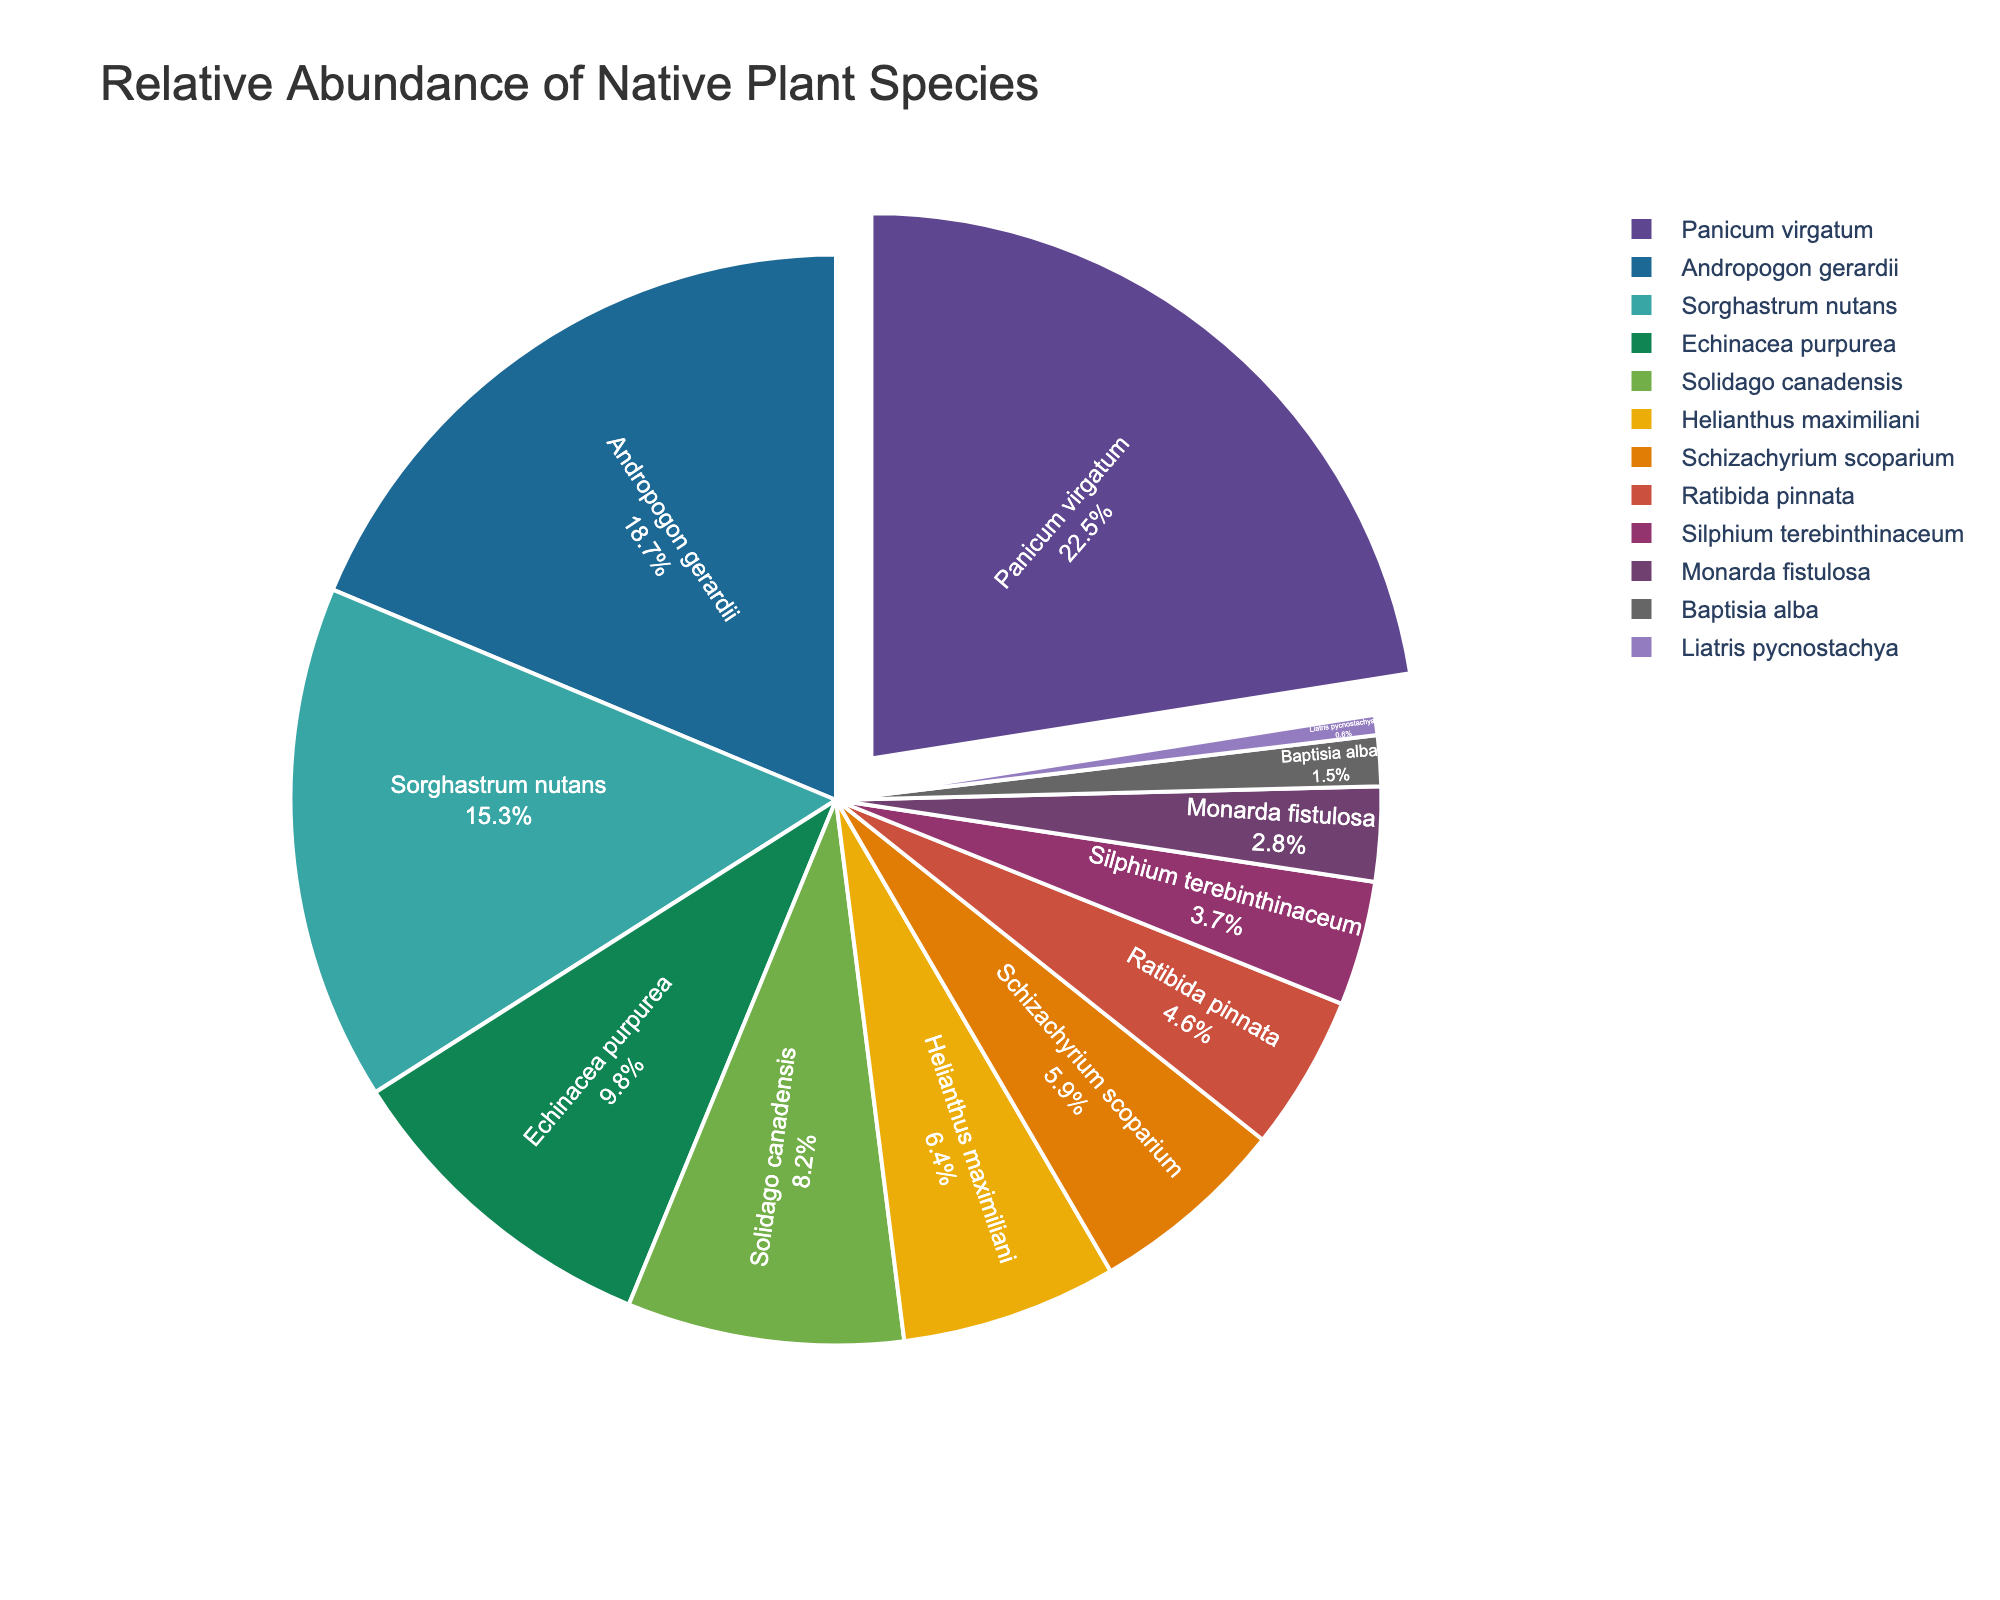What is the most abundant species in the area? The most abundant species will be the one with the largest section in the pie chart. According to the data, Panicum virgatum has the highest relative abundance at 22.5%.
Answer: Panicum virgatum What species has a relative abundance closest to 10%? Look at the sectors in the pie chart near the 10% mark. Echinacea purpurea has a relative abundance of 9.8%, which is the closest to 10%.
Answer: Echinacea purpurea Which species has the smallest relative abundance? Identify the smallest sector in the pie chart. Liatris pycnostachya has the smallest relative abundance at 0.6%.
Answer: Liatris pycnostachya How much is the combined relative abundance of the three most dominant species? Sum the relative abundances of Panicum virgatum (22.5%), Andropogon gerardii (18.7%), and Sorghastrum nutans (15.3%). The combined value is 22.5 + 18.7 + 15.3 = 56.5%.
Answer: 56.5% Which species has a higher relative abundance: Helianthus maximiliani or Ratibida pinnata? Compare the relative abundances of Helianthus maximiliani (6.4%) and Ratibida pinnata (4.6%). Helianthus maximiliani has a higher relative abundance.
Answer: Helianthus maximiliani What is the total relative abundance of the two least abundant species? The two least abundant species are Liatris pycnostachya (0.6%) and Baptisia alba (1.5%). Their combined abundance is 0.6 + 1.5 = 2.1%.
Answer: 2.1% Is the relative abundance of Solidago canadensis more than double that of Monarda fistulosa? Compare the two values: Solidago canadensis is 8.2% and Monarda fistulosa is 2.8%. Double of Monarda fistulosa is 2.8 * 2 = 5.6%, and 8.2% is indeed more than double 2.8%.
Answer: Yes What is the difference in relative abundance between the species ranked fourth and fifth? The fourth-ranked species is Echinacea purpurea (9.8%) and the fifth is Solidago canadensis (8.2%). The difference is 9.8 - 8.2 = 1.6%.
Answer: 1.6% If the study aimed to increase the relative abundance of Schizachyrium scoparium to that of Andropogon gerardii's level, by how many percentage points would it need to increase? Schizachyrium scoparium has 5.9% relative abundance and Andropogon gerardii has 18.7%. Subtract 5.9 from 18.7 to find the required increase: 18.7 - 5.9 = 12.8%.
Answer: 12.8% 